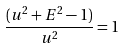Convert formula to latex. <formula><loc_0><loc_0><loc_500><loc_500>\frac { ( u ^ { 2 } + E ^ { 2 } - 1 ) } { u ^ { 2 } } = 1</formula> 